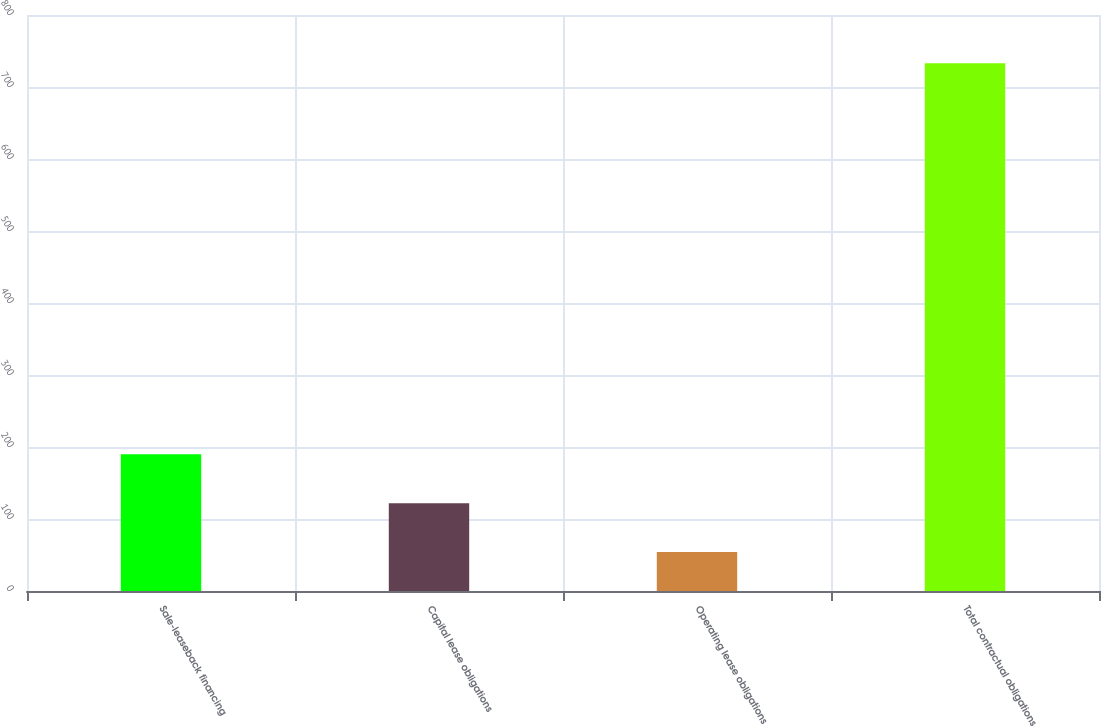Convert chart. <chart><loc_0><loc_0><loc_500><loc_500><bar_chart><fcel>Sale-leaseback financing<fcel>Capital lease obligations<fcel>Operating lease obligations<fcel>Total contractual obligations<nl><fcel>189.8<fcel>121.9<fcel>54<fcel>733<nl></chart> 